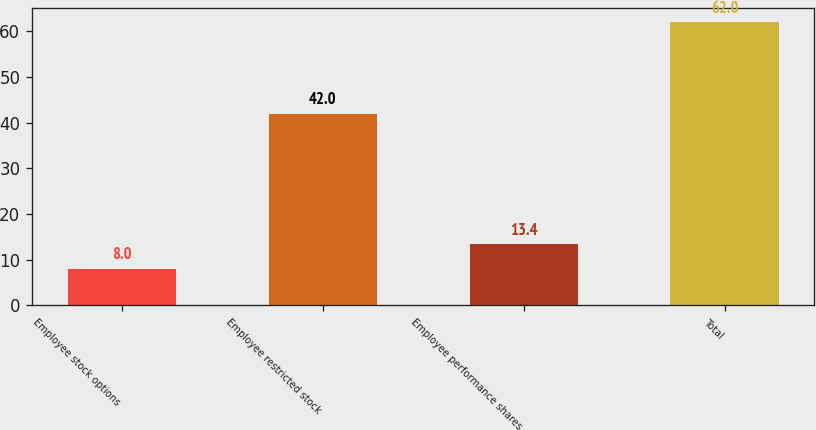Convert chart to OTSL. <chart><loc_0><loc_0><loc_500><loc_500><bar_chart><fcel>Employee stock options<fcel>Employee restricted stock<fcel>Employee performance shares<fcel>Total<nl><fcel>8<fcel>42<fcel>13.4<fcel>62<nl></chart> 